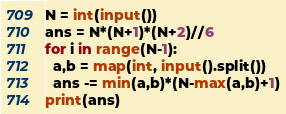Convert code to text. <code><loc_0><loc_0><loc_500><loc_500><_Python_>N = int(input())
ans = N*(N+1)*(N+2)//6
for i in range(N-1):
  a,b = map(int, input().split())
  ans -= min(a,b)*(N-max(a,b)+1)
print(ans)</code> 